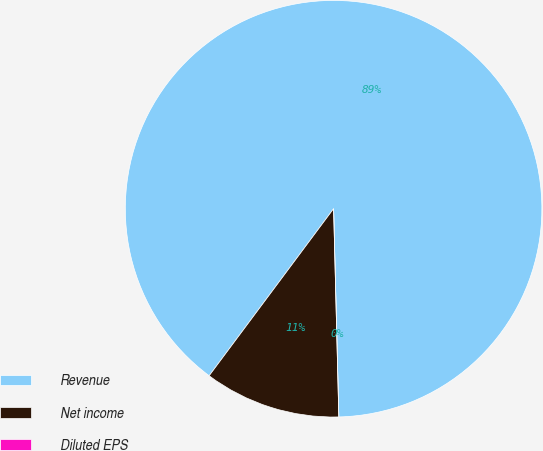Convert chart to OTSL. <chart><loc_0><loc_0><loc_500><loc_500><pie_chart><fcel>Revenue<fcel>Net income<fcel>Diluted EPS<nl><fcel>89.41%<fcel>10.59%<fcel>0.0%<nl></chart> 